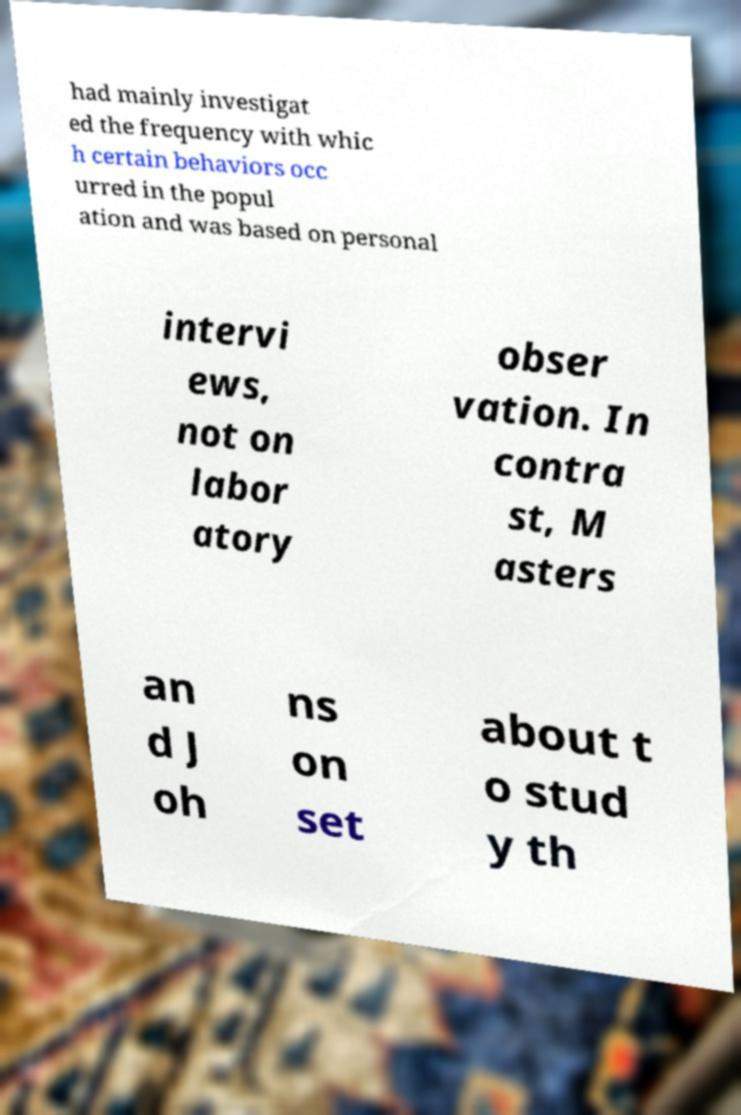Can you read and provide the text displayed in the image?This photo seems to have some interesting text. Can you extract and type it out for me? had mainly investigat ed the frequency with whic h certain behaviors occ urred in the popul ation and was based on personal intervi ews, not on labor atory obser vation. In contra st, M asters an d J oh ns on set about t o stud y th 